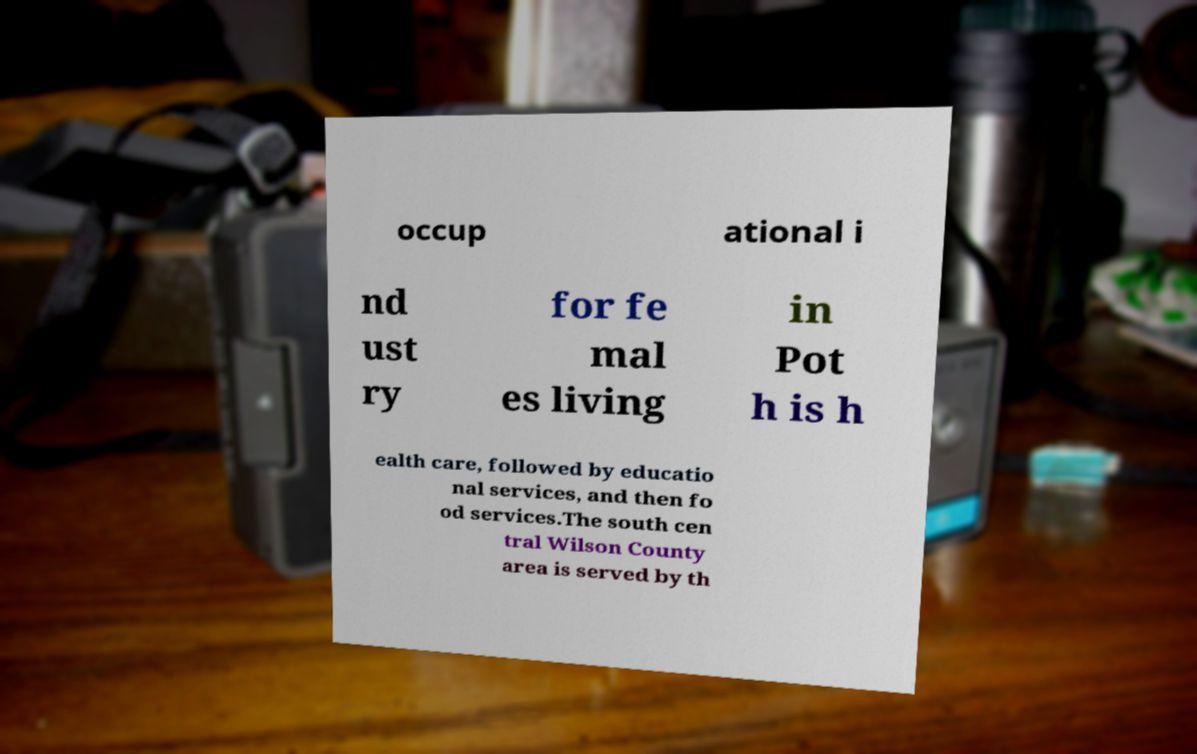For documentation purposes, I need the text within this image transcribed. Could you provide that? occup ational i nd ust ry for fe mal es living in Pot h is h ealth care, followed by educatio nal services, and then fo od services.The south cen tral Wilson County area is served by th 